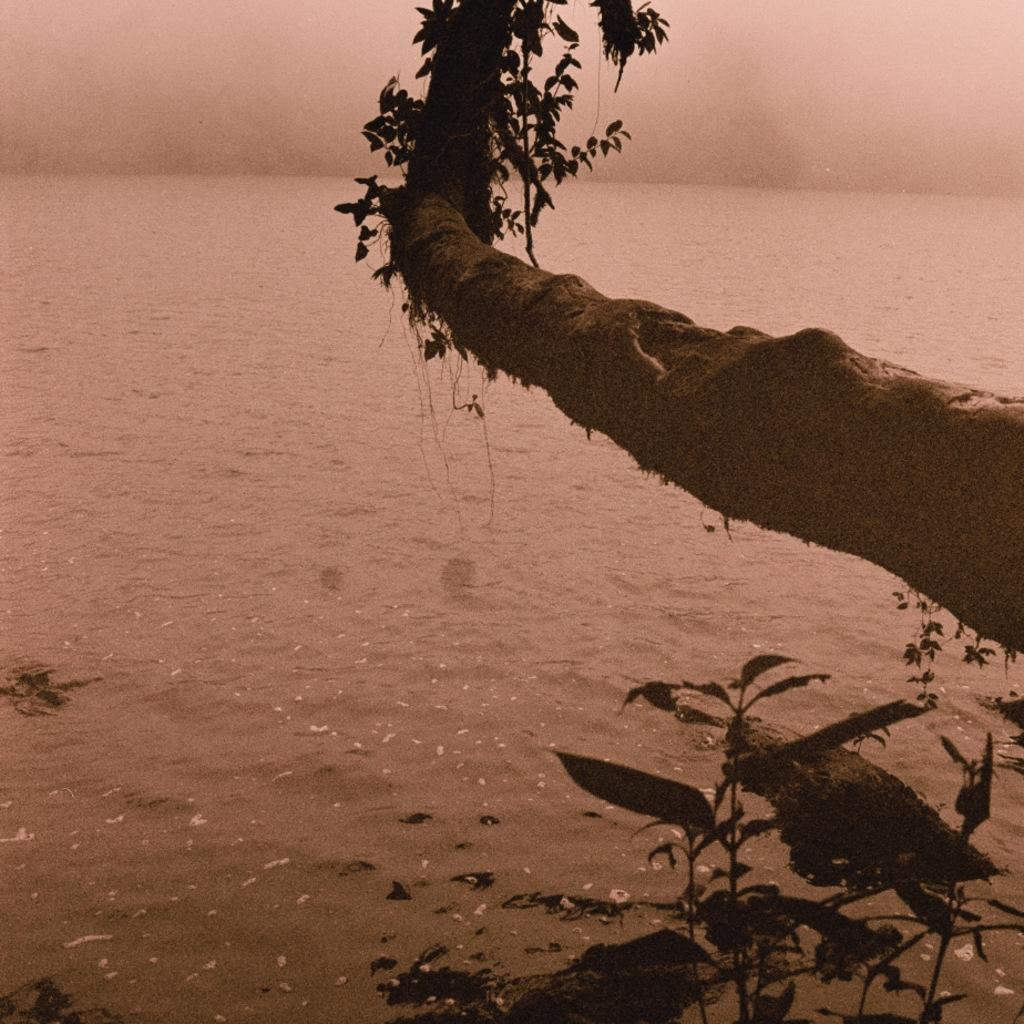What is the main object in the image? There is a branch of a tree in the image. What other natural elements can be seen in the image? There are plants and water visible in the image. What is visible in the background of the image? The sky is visible in the background of the image. How many layers of cake can be seen in the image? There is no cake present in the image. What type of cactus is growing near the water in the image? There is no cactus present in the image. 